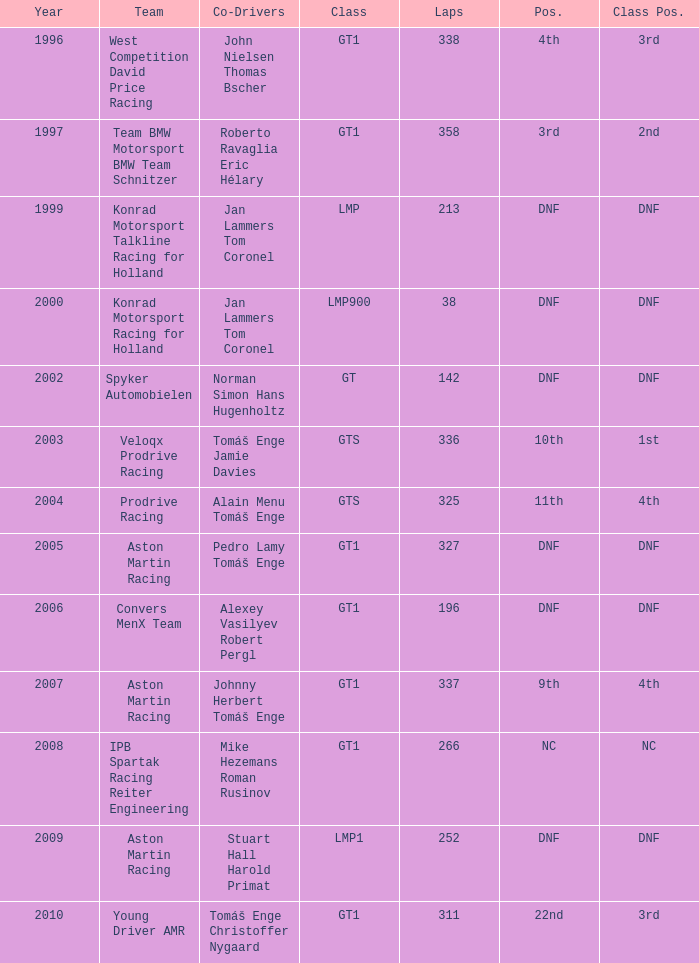Which class had a participant with dnf status after completing 252 laps? LMP1. 